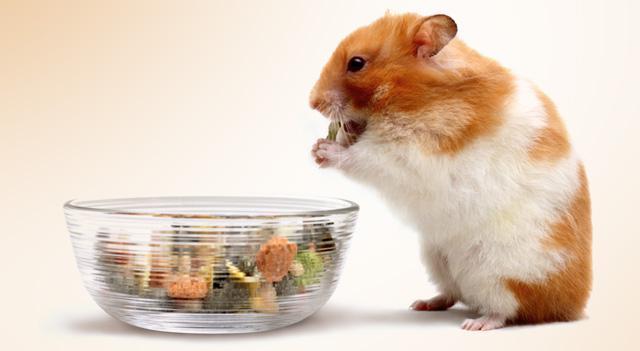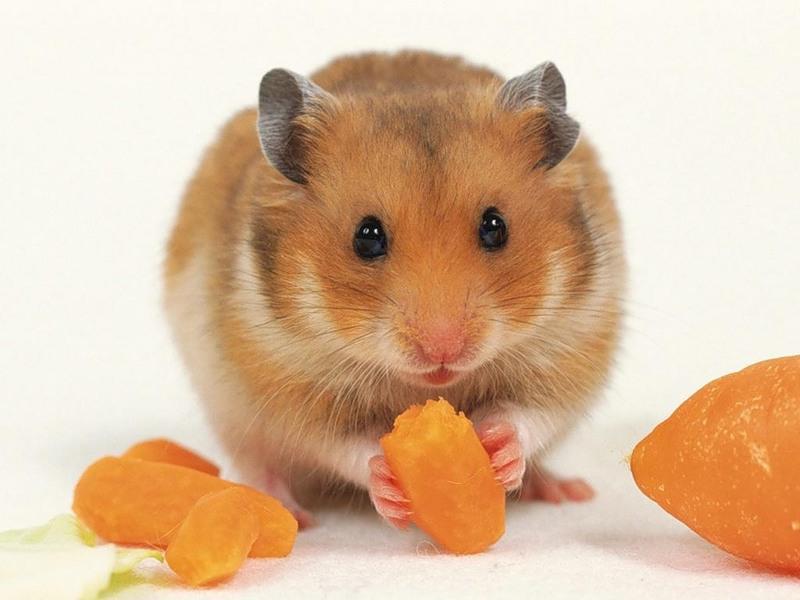The first image is the image on the left, the second image is the image on the right. Analyze the images presented: Is the assertion "All of the hamsters are eating." valid? Answer yes or no. Yes. 